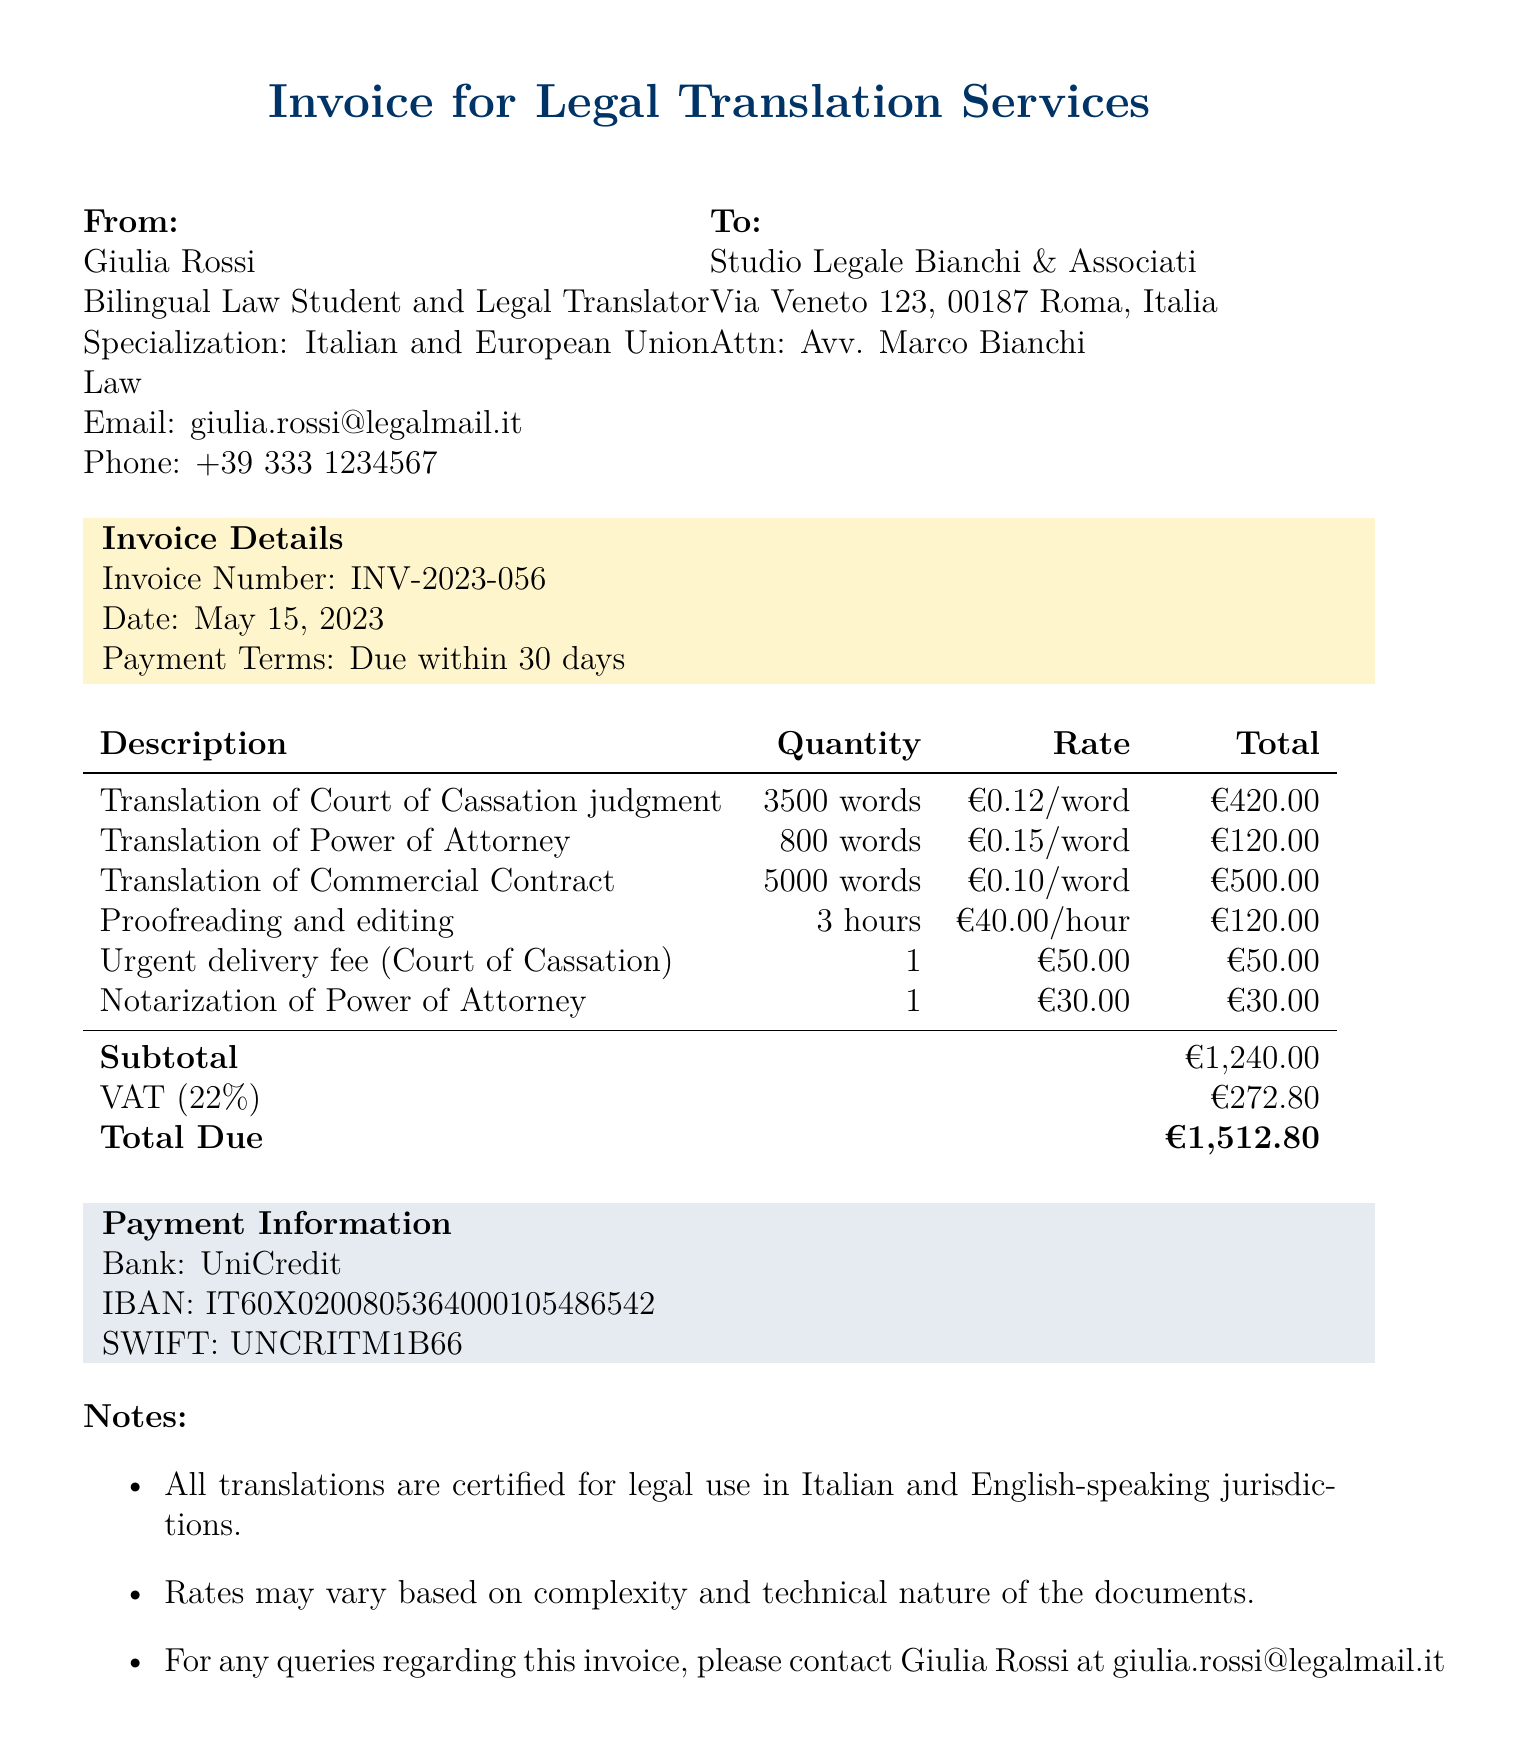What is the name of the translator? The document states the translator's name is Giulia Rossi.
Answer: Giulia Rossi What is the total due amount? The total amount due is clearly indicated in the payment information section of the document.
Answer: €1,512.80 What is the VAT rate applied to the invoice? The VAT rate is mentioned in the payment information as 22%.
Answer: 22% How many words were translated for the Commercial Contract? The document specifies that 5000 words were translated for the Commercial Contract.
Answer: 5000 words What is the flat rate for the urgent delivery fee? The document lists the urgent delivery fee as a flat rate in the additional services section.
Answer: €50.00 Which legal specialization does the translator have? The translator's specialization is stated at the beginning of the document.
Answer: Italian and European Union Law How many hours were spent on proofreading and editing? The number of hours spent on proofreading and editing is detailed in the services rendered section of the document.
Answer: 3 hours Who is the contact person for the client? The contact person for the client is clearly indicated in the client information section.
Answer: Avv. Marco Bianchi What is the email address of the translator? The document provides a contact email for the translator in the translator information section.
Answer: giulia.rossi@legalmail.it 